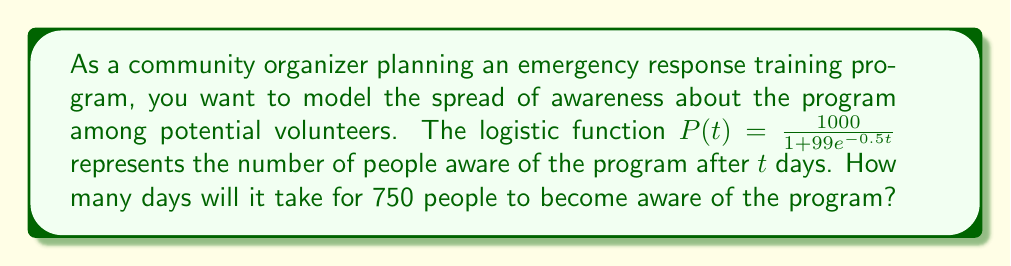Provide a solution to this math problem. To solve this problem, we need to use the given logistic function and find the value of $t$ when $P(t) = 750$. Let's approach this step-by-step:

1) We start with the equation:
   $\frac{1000}{1 + 99e^{-0.5t}} = 750$

2) Multiply both sides by $(1 + 99e^{-0.5t})$:
   $1000 = 750(1 + 99e^{-0.5t})$

3) Expand the right side:
   $1000 = 750 + 74250e^{-0.5t}$

4) Subtract 750 from both sides:
   $250 = 74250e^{-0.5t}$

5) Divide both sides by 74250:
   $\frac{250}{74250} = e^{-0.5t}$

6) Take the natural log of both sides:
   $\ln(\frac{250}{74250}) = -0.5t$

7) Solve for $t$:
   $t = -\frac{2}{0.5}\ln(\frac{250}{74250}) \approx 10.99$

8) Since we're dealing with days, we round up to the nearest whole number.
Answer: 11 days 